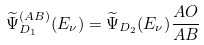<formula> <loc_0><loc_0><loc_500><loc_500>\widetilde { \Psi } _ { D _ { 1 } } ^ { ( A B ) } ( E _ { \nu } ) = \widetilde { \Psi } _ { D _ { 2 } } ( E _ { \nu } ) \frac { A O } { A B }</formula> 